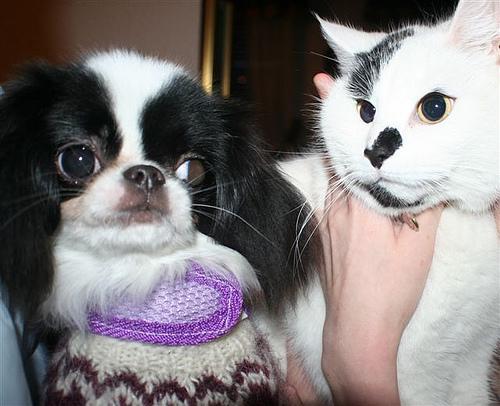What is the dog wearing?
Be succinct. Sweater. Are both animals black and white?
Answer briefly. Yes. Do either of the animals look interested in the photo?
Write a very short answer. No. 